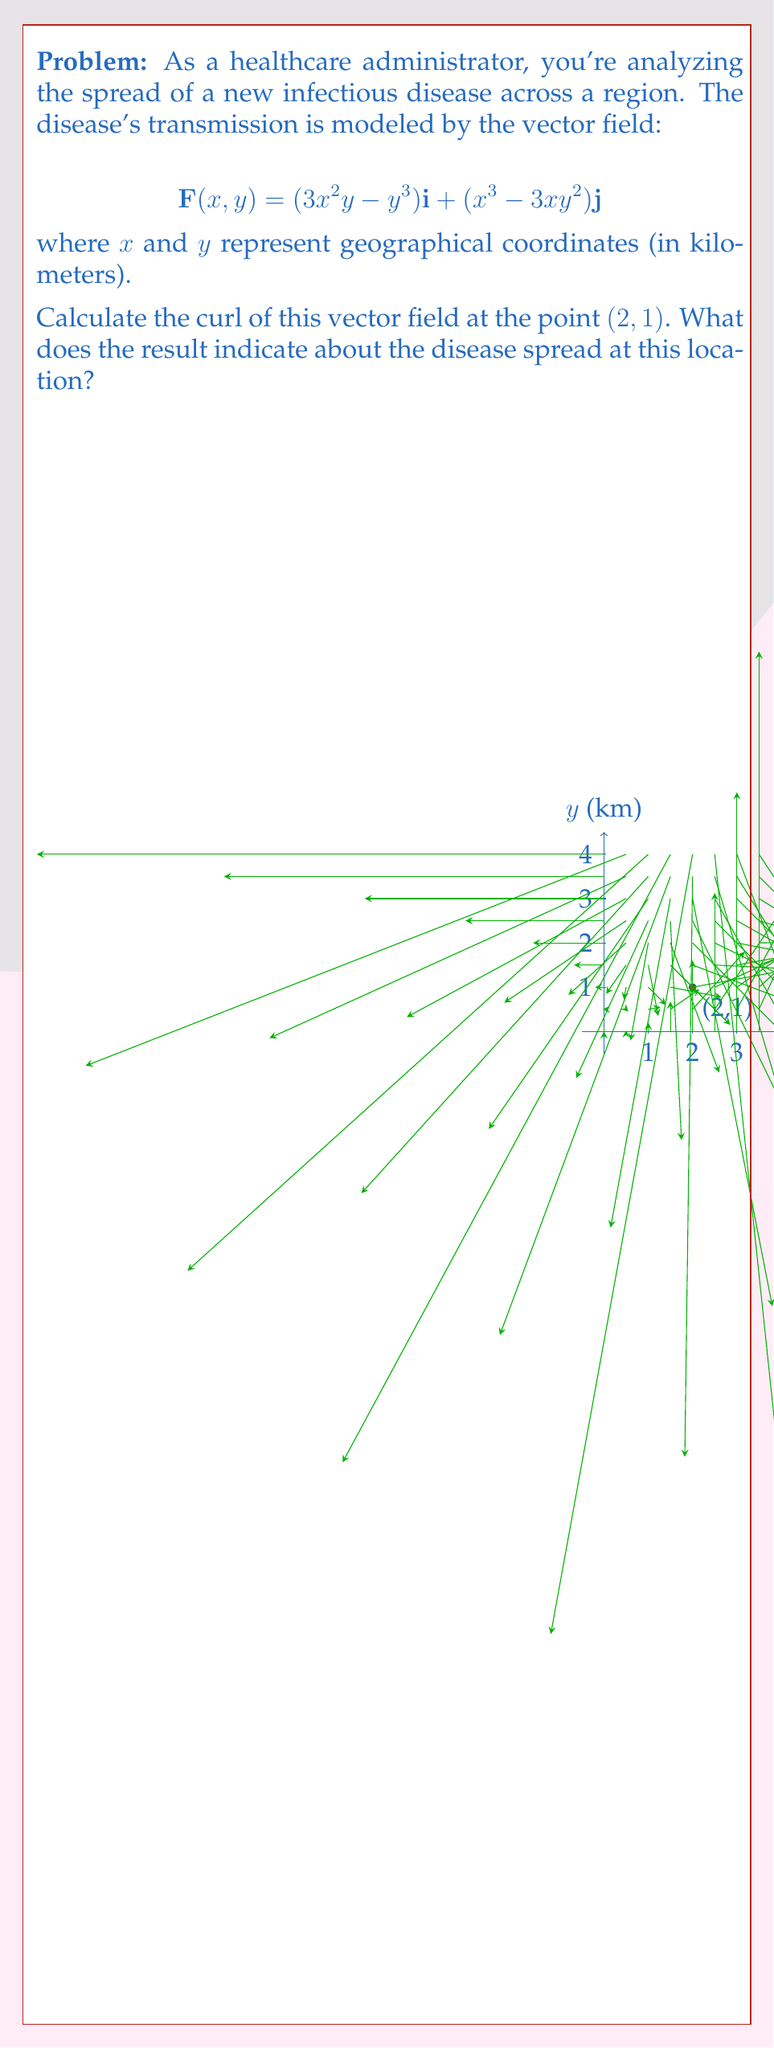Teach me how to tackle this problem. Let's approach this step-by-step:

1) The curl of a vector field $\mathbf{F}(x,y) = P(x,y)\mathbf{i} + Q(x,y)\mathbf{j}$ in two dimensions is given by:

   $$\text{curl }\mathbf{F} = \frac{\partial Q}{\partial x} - \frac{\partial P}{\partial y}$$

2) In our case:
   $P(x,y) = 3x^2y - y^3$
   $Q(x,y) = x^3 - 3xy^2$

3) Let's calculate the partial derivatives:

   $\frac{\partial Q}{\partial x} = 3x^2 - 3y^2$
   
   $\frac{\partial P}{\partial y} = 3x^2 - 3y^2$

4) Now, we can calculate the curl:

   $$\text{curl }\mathbf{F} = (3x^2 - 3y^2) - (3x^2 - 3y^2) = 0$$

5) This result is true for all points $(x,y)$, including $(2,1)$.

6) In the context of disease spread, a curl of zero indicates that there is no rotational component to the vector field at this point. This means that the disease is not spreading in a way that creates localized "hotspots" or "vortices" of infection at $(2,1)$.

7) However, this doesn't mean the disease isn't spreading. The vector field still has non-zero components, indicating linear spread in both x and y directions.
Answer: Curl = 0; indicates no rotational spread at (2,1). 